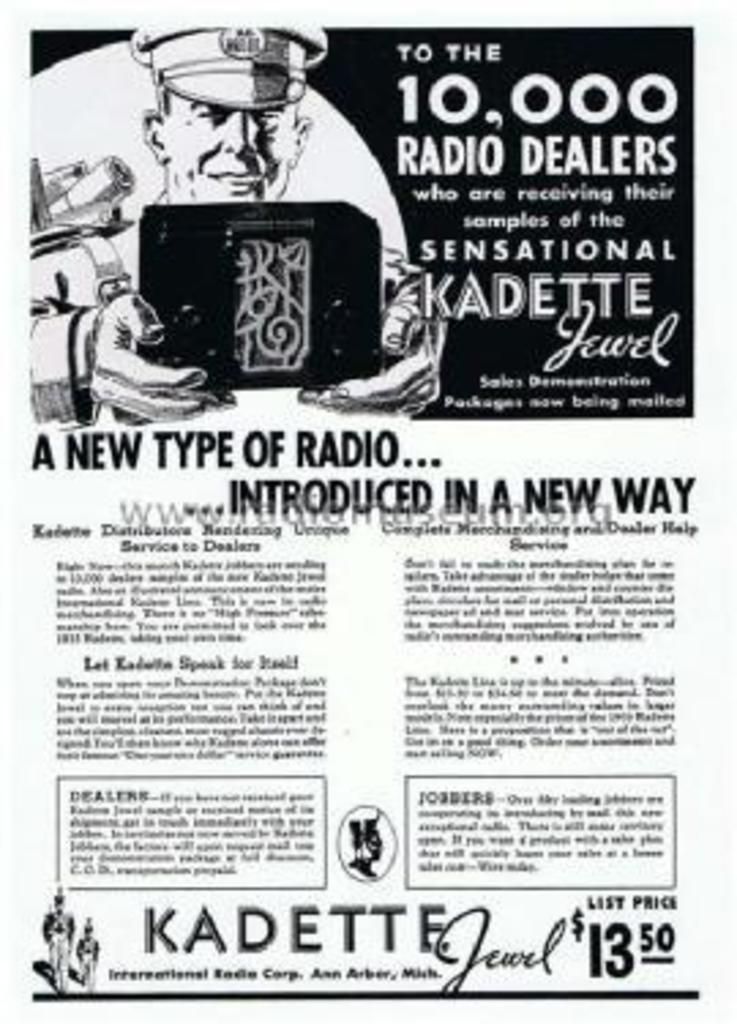<image>
Relay a brief, clear account of the picture shown. An old advertisement says kadette at the bottom of it. 